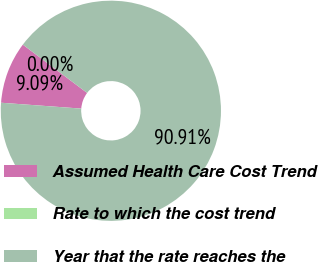<chart> <loc_0><loc_0><loc_500><loc_500><pie_chart><fcel>Assumed Health Care Cost Trend<fcel>Rate to which the cost trend<fcel>Year that the rate reaches the<nl><fcel>9.09%<fcel>0.0%<fcel>90.91%<nl></chart> 